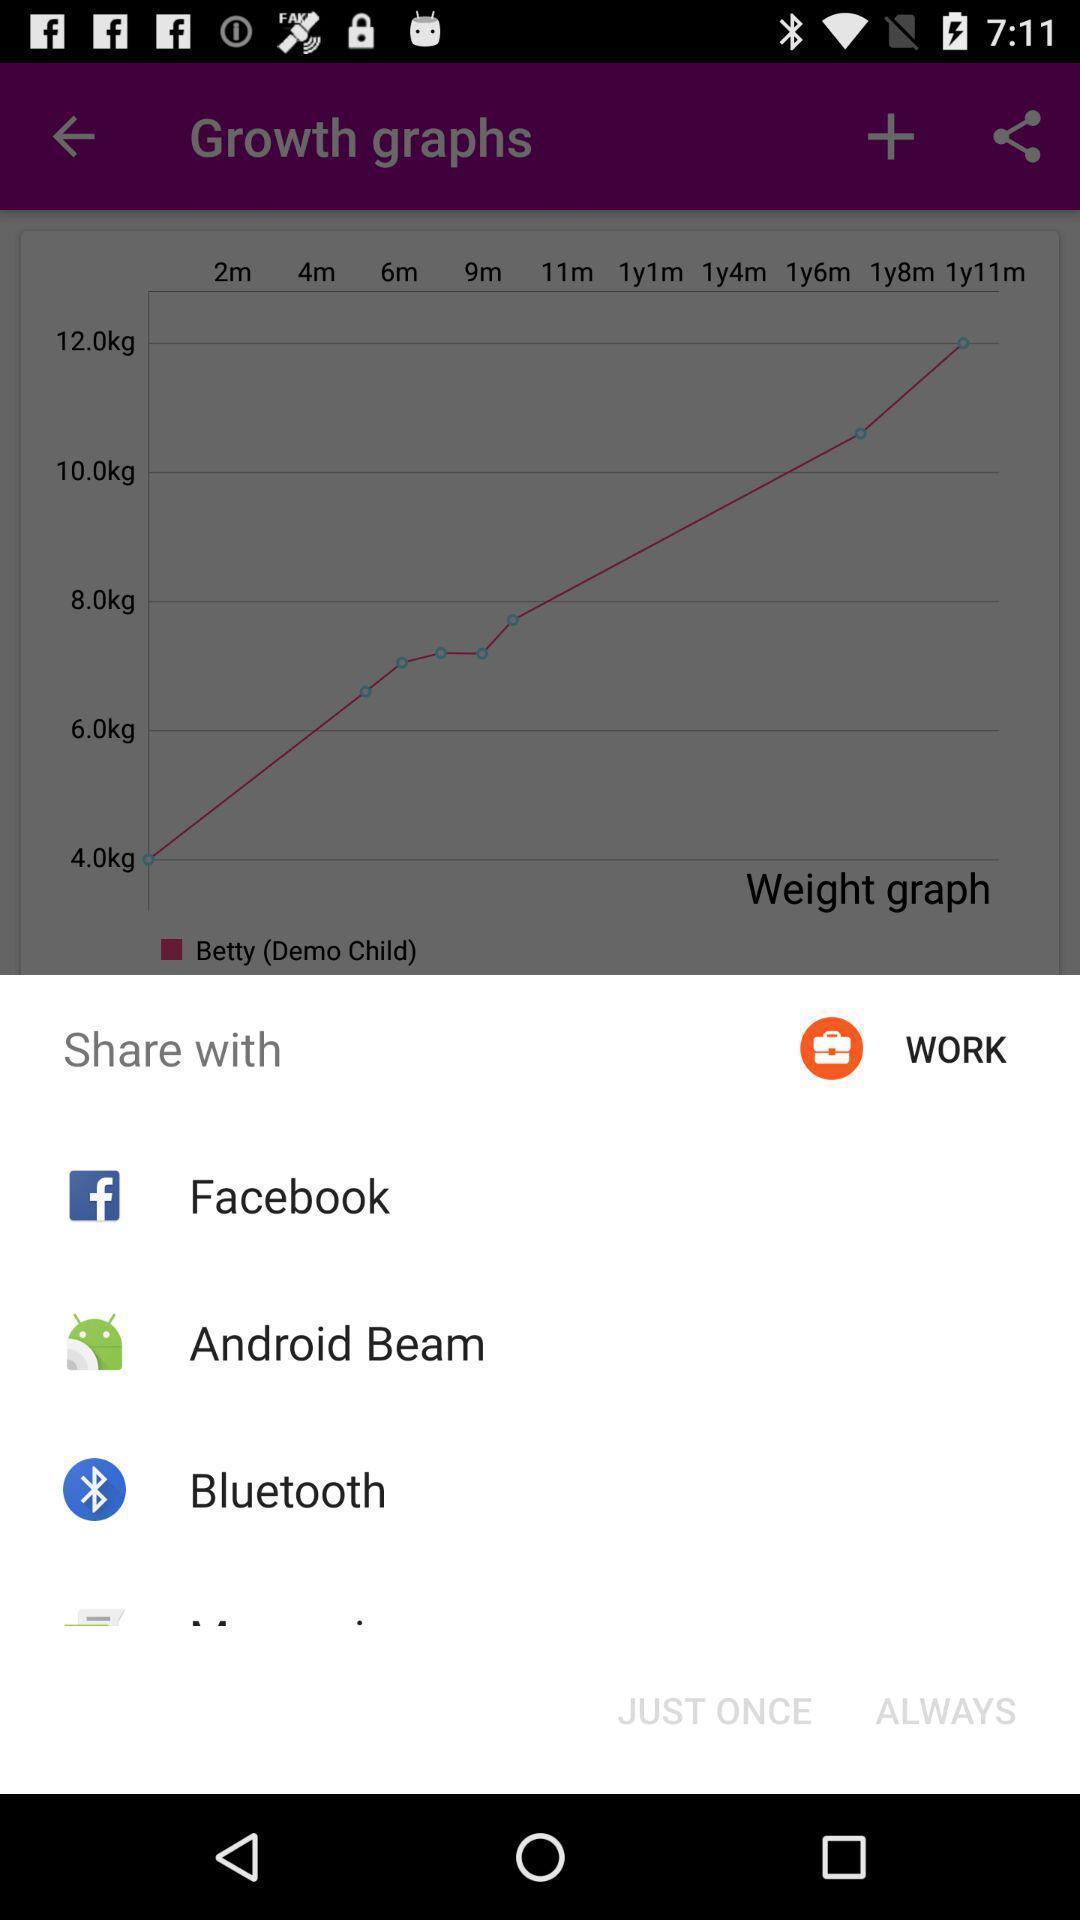Give me a summary of this screen capture. Pop-up showing various sharing options. 